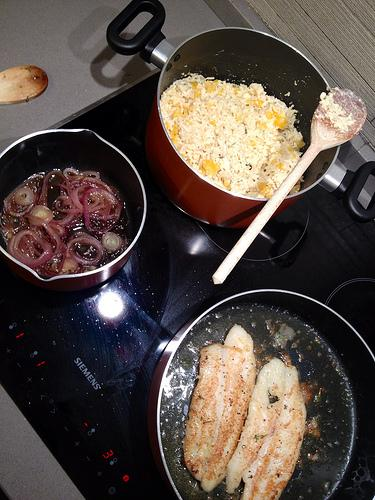Give a detailed description of the wooden spoon's appearance and position in the image. The wooden cooking spoon has a serving end and a handle, with part of it on the red pot and another part on the countertop. List the different pots, pans and their contents visible in the image. A red cooking pot with rice, a red frying pan with cutlets and fish, a metal pot with simmering food, and a pan with sauteed onions. Describe the stove and any unique features in the image. A flameless Siemens stovetop with red lit-up numbers is being used for cooking various food items on range top number 3. Provide a brief overview of the entire scene in the image. Various pots, pans, and cooking utensils are on a stove, with food items like cutlets, fish, onions, and rice being prepared and cooked. Detail the location of the cooking items in relation to the stovetop numbers and lit-up features. Onions cook in oil near number 1, a Siemens logo is by number 3, rice is on a wooden spoon near the red lit-up numbers, and food is on range top 3. Explain what type of food is being cooked in the image. Cutlets and fish are frying in pans, onions are sauteing, and rice is being cooked in a pot on the stove. Mention the specific items being used for cooking in the scene. A wooden spoon, metal pan, plastic handles, red cooking pot, and red frying pan are being used for cooking on a Siemens stove. State the food items and cooking utensils in the image, with particular focus on materials and colors. There are cutlets, fried fish, rice, and onions being cooked in metal and red pots and pans, with a wooden spoon and black plastic handles. Describe any food items that are being cooked on the stovetop and mention their condition. Cutlets are frying and browning on top, onions are simmering in oil, fish is seasoned and oily, and rice is being cooked in a pot. Mention any noticeable food garnishing or serving techniques in the image. Green herbs are sprinkled on the fried fish, and a wooden spoon is being used to serve rice from a pot. 